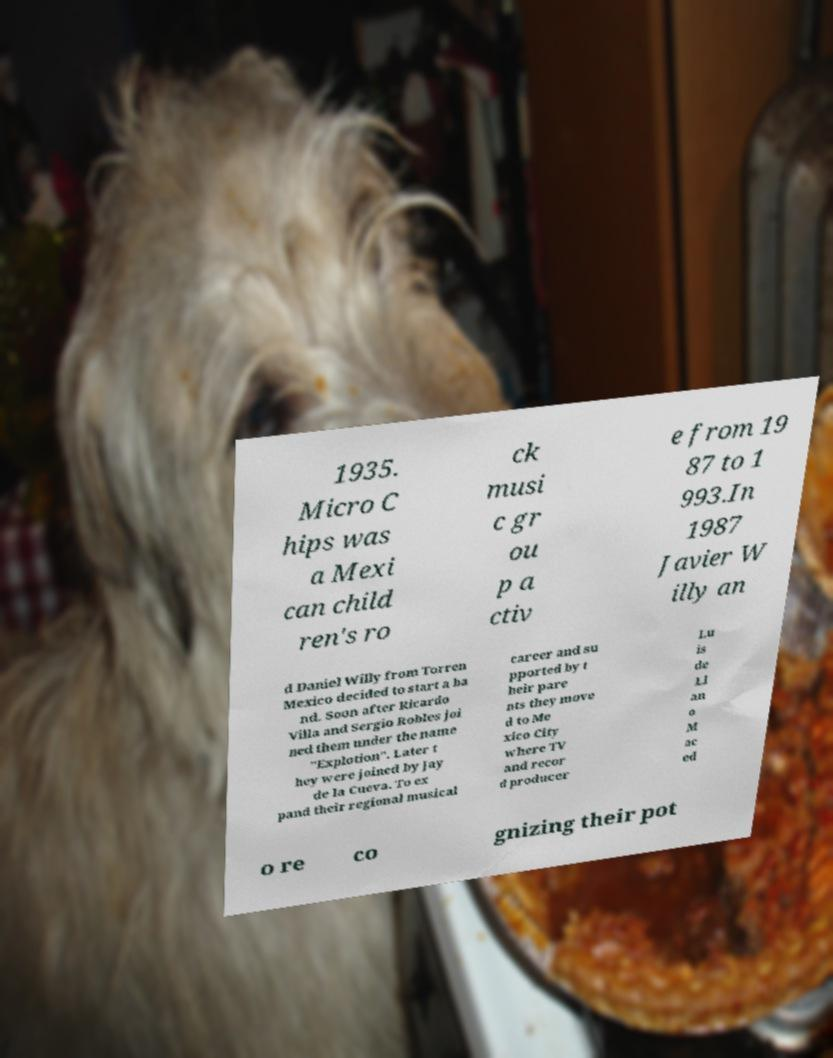There's text embedded in this image that I need extracted. Can you transcribe it verbatim? 1935. Micro C hips was a Mexi can child ren's ro ck musi c gr ou p a ctiv e from 19 87 to 1 993.In 1987 Javier W illy an d Daniel Willy from Torren Mexico decided to start a ba nd. Soon after Ricardo Villa and Sergio Robles joi ned them under the name "Explotion". Later t hey were joined by Jay de la Cueva. To ex pand their regional musical career and su pported by t heir pare nts they move d to Me xico City where TV and recor d producer Lu is de Ll an o M ac ed o re co gnizing their pot 